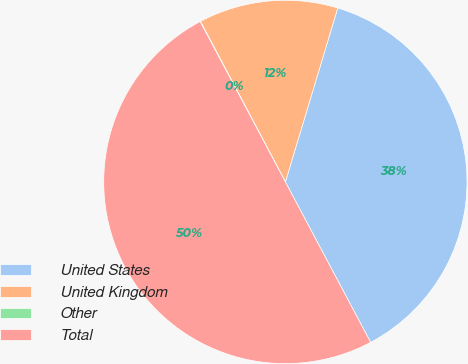Convert chart to OTSL. <chart><loc_0><loc_0><loc_500><loc_500><pie_chart><fcel>United States<fcel>United Kingdom<fcel>Other<fcel>Total<nl><fcel>37.57%<fcel>12.4%<fcel>0.03%<fcel>50.0%<nl></chart> 